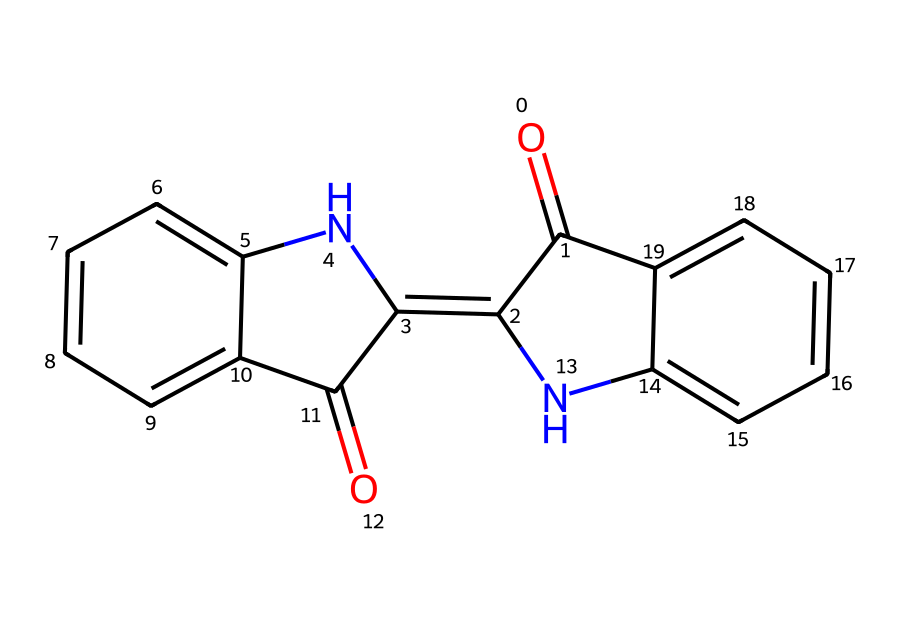How many rings are present in the structure? The chemical structure reveals two distinct aromatic rings as highlighted by the fused benzene-like portions in the molecule. These rings are crucial for the dye's properties.
Answer: two What type of bonding is primarily observed in this chemical? The structure contains multiple double bonds and aromatic rings indicating a significant presence of covalent bonding throughout the molecule, contributing to its stability and color characteristics.
Answer: covalent Which atom is responsible for the nitrogen presence in the dye? The structure shows two nitrogen atoms included within the fused ring systems, indicating the molecule incorporates these atoms into its chemical framework, contributing to its overall structure and properties as a dye.
Answer: nitrogen What is the molecular formula derived from this SMILES representation? By analyzing the structure and tallying the atoms, the molecular formula can be calculated as C16H10N2O2, representing the components necessary for the indigo dye known for its deep blue color.
Answer: C16H10N2O2 What aromatic features are present in this indigo dye? The molecule consists of two aromatic rings which contribute to its color and light-absorbing characteristics; the alternating double bonds are key features of aromatic compounds.
Answer: aromatic rings What is the color characteristic of this dye derived from its structure? Due to its structure and the specific arrangement of conjugated double bonds, indigo is characterized by its deep blue color, which is prominently utilized in dyeing textiles.
Answer: blue 